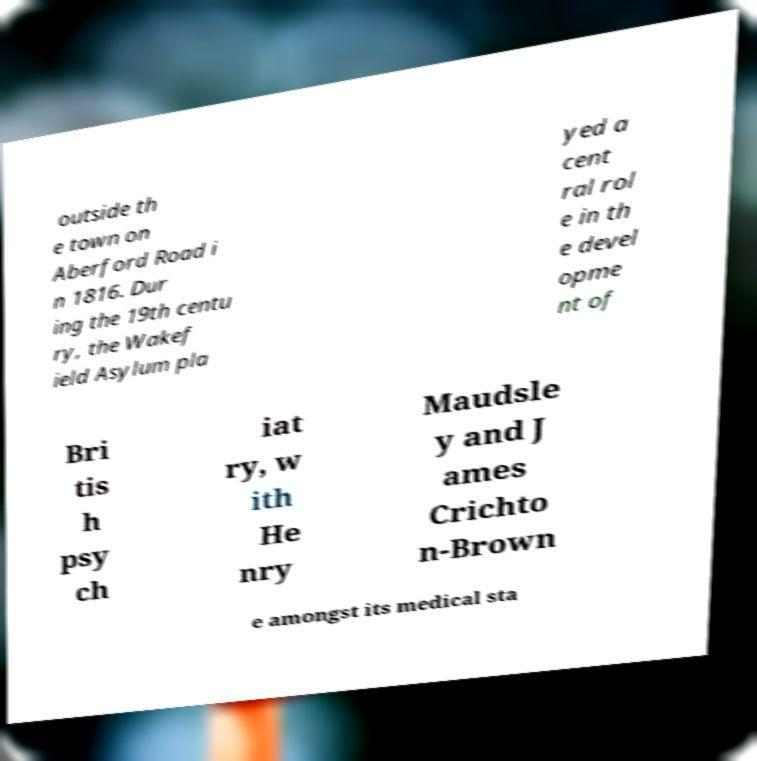Could you assist in decoding the text presented in this image and type it out clearly? outside th e town on Aberford Road i n 1816. Dur ing the 19th centu ry, the Wakef ield Asylum pla yed a cent ral rol e in th e devel opme nt of Bri tis h psy ch iat ry, w ith He nry Maudsle y and J ames Crichto n-Brown e amongst its medical sta 